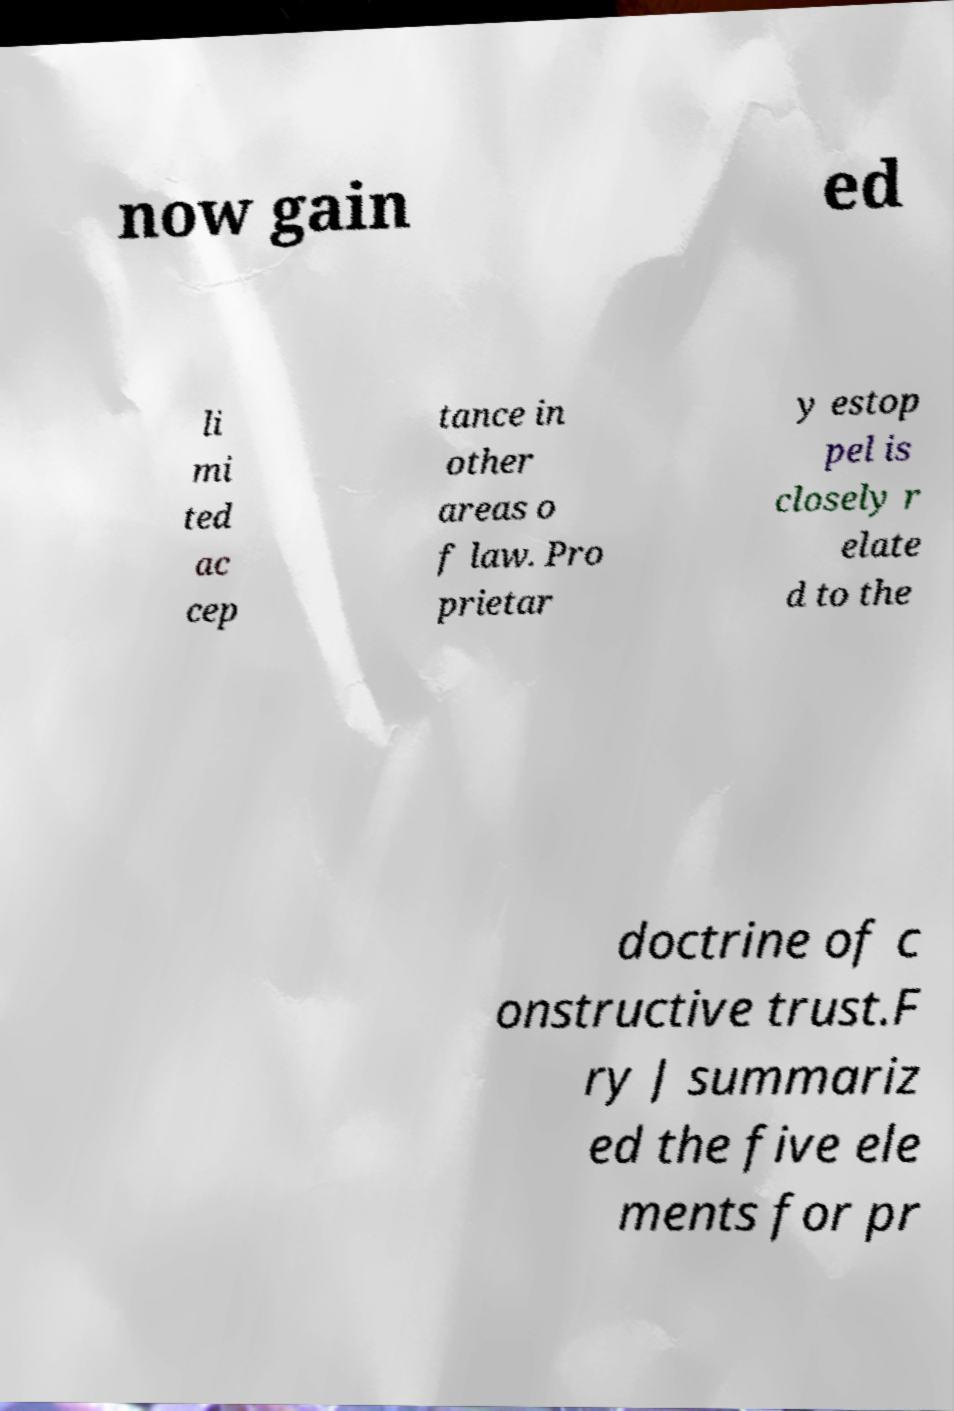Can you read and provide the text displayed in the image?This photo seems to have some interesting text. Can you extract and type it out for me? now gain ed li mi ted ac cep tance in other areas o f law. Pro prietar y estop pel is closely r elate d to the doctrine of c onstructive trust.F ry J summariz ed the five ele ments for pr 